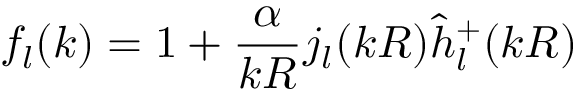<formula> <loc_0><loc_0><loc_500><loc_500>f _ { l } ( k ) = 1 + \frac { \alpha } { k R } j _ { l } ( k R ) \hat { h } _ { l } ^ { + } ( k R )</formula> 